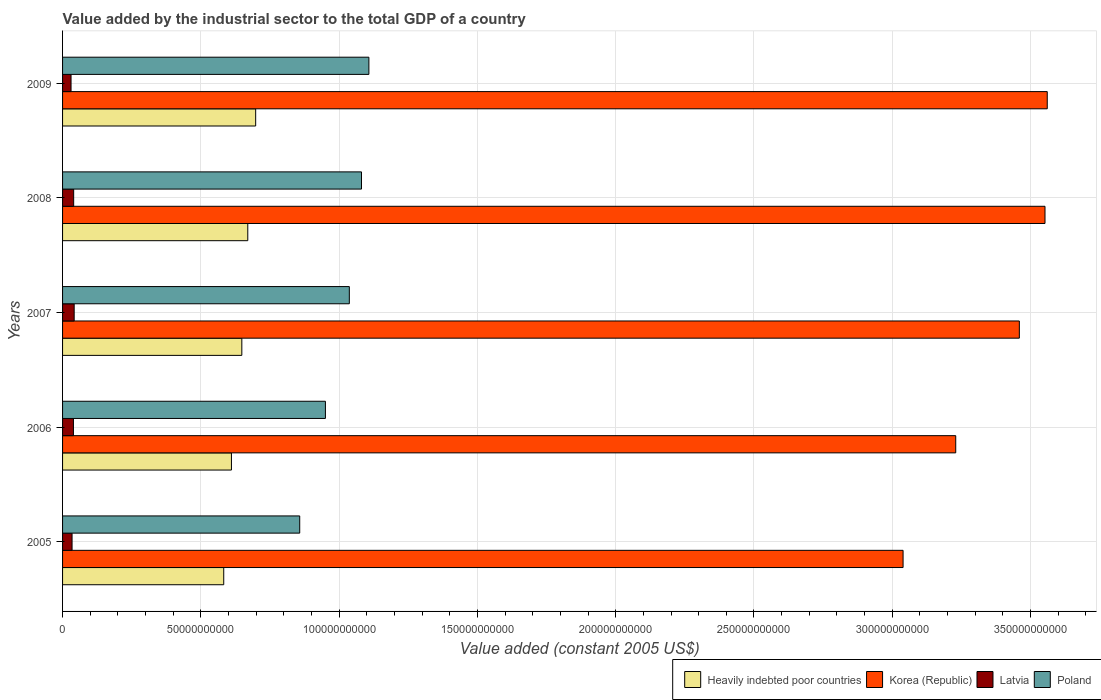How many different coloured bars are there?
Give a very brief answer. 4. How many bars are there on the 1st tick from the top?
Offer a very short reply. 4. In how many cases, is the number of bars for a given year not equal to the number of legend labels?
Keep it short and to the point. 0. What is the value added by the industrial sector in Korea (Republic) in 2008?
Provide a succinct answer. 3.55e+11. Across all years, what is the maximum value added by the industrial sector in Korea (Republic)?
Offer a terse response. 3.56e+11. Across all years, what is the minimum value added by the industrial sector in Latvia?
Give a very brief answer. 3.06e+09. In which year was the value added by the industrial sector in Latvia maximum?
Give a very brief answer. 2007. What is the total value added by the industrial sector in Poland in the graph?
Offer a very short reply. 5.03e+11. What is the difference between the value added by the industrial sector in Heavily indebted poor countries in 2005 and that in 2007?
Offer a very short reply. -6.54e+09. What is the difference between the value added by the industrial sector in Poland in 2006 and the value added by the industrial sector in Heavily indebted poor countries in 2008?
Your answer should be very brief. 2.81e+1. What is the average value added by the industrial sector in Poland per year?
Your response must be concise. 1.01e+11. In the year 2005, what is the difference between the value added by the industrial sector in Heavily indebted poor countries and value added by the industrial sector in Korea (Republic)?
Keep it short and to the point. -2.46e+11. In how many years, is the value added by the industrial sector in Poland greater than 340000000000 US$?
Make the answer very short. 0. What is the ratio of the value added by the industrial sector in Poland in 2005 to that in 2009?
Your answer should be compact. 0.77. Is the value added by the industrial sector in Poland in 2008 less than that in 2009?
Keep it short and to the point. Yes. What is the difference between the highest and the second highest value added by the industrial sector in Latvia?
Your answer should be compact. 1.83e+08. What is the difference between the highest and the lowest value added by the industrial sector in Poland?
Provide a short and direct response. 2.50e+1. In how many years, is the value added by the industrial sector in Korea (Republic) greater than the average value added by the industrial sector in Korea (Republic) taken over all years?
Provide a short and direct response. 3. Is it the case that in every year, the sum of the value added by the industrial sector in Heavily indebted poor countries and value added by the industrial sector in Korea (Republic) is greater than the sum of value added by the industrial sector in Latvia and value added by the industrial sector in Poland?
Provide a succinct answer. No. What does the 3rd bar from the top in 2007 represents?
Ensure brevity in your answer.  Korea (Republic). What does the 1st bar from the bottom in 2006 represents?
Provide a short and direct response. Heavily indebted poor countries. How many years are there in the graph?
Ensure brevity in your answer.  5. What is the difference between two consecutive major ticks on the X-axis?
Keep it short and to the point. 5.00e+1. Does the graph contain grids?
Keep it short and to the point. Yes. Where does the legend appear in the graph?
Keep it short and to the point. Bottom right. How many legend labels are there?
Ensure brevity in your answer.  4. What is the title of the graph?
Your response must be concise. Value added by the industrial sector to the total GDP of a country. What is the label or title of the X-axis?
Offer a terse response. Value added (constant 2005 US$). What is the label or title of the Y-axis?
Make the answer very short. Years. What is the Value added (constant 2005 US$) in Heavily indebted poor countries in 2005?
Provide a succinct answer. 5.83e+1. What is the Value added (constant 2005 US$) in Korea (Republic) in 2005?
Your answer should be compact. 3.04e+11. What is the Value added (constant 2005 US$) of Latvia in 2005?
Provide a short and direct response. 3.44e+09. What is the Value added (constant 2005 US$) of Poland in 2005?
Keep it short and to the point. 8.57e+1. What is the Value added (constant 2005 US$) of Heavily indebted poor countries in 2006?
Your response must be concise. 6.11e+1. What is the Value added (constant 2005 US$) in Korea (Republic) in 2006?
Your answer should be compact. 3.23e+11. What is the Value added (constant 2005 US$) in Latvia in 2006?
Offer a very short reply. 3.93e+09. What is the Value added (constant 2005 US$) in Poland in 2006?
Your answer should be very brief. 9.50e+1. What is the Value added (constant 2005 US$) of Heavily indebted poor countries in 2007?
Your answer should be very brief. 6.48e+1. What is the Value added (constant 2005 US$) of Korea (Republic) in 2007?
Your answer should be very brief. 3.46e+11. What is the Value added (constant 2005 US$) of Latvia in 2007?
Offer a very short reply. 4.20e+09. What is the Value added (constant 2005 US$) in Poland in 2007?
Offer a very short reply. 1.04e+11. What is the Value added (constant 2005 US$) of Heavily indebted poor countries in 2008?
Provide a short and direct response. 6.70e+1. What is the Value added (constant 2005 US$) in Korea (Republic) in 2008?
Your response must be concise. 3.55e+11. What is the Value added (constant 2005 US$) in Latvia in 2008?
Provide a short and direct response. 4.01e+09. What is the Value added (constant 2005 US$) of Poland in 2008?
Make the answer very short. 1.08e+11. What is the Value added (constant 2005 US$) of Heavily indebted poor countries in 2009?
Give a very brief answer. 6.98e+1. What is the Value added (constant 2005 US$) in Korea (Republic) in 2009?
Ensure brevity in your answer.  3.56e+11. What is the Value added (constant 2005 US$) of Latvia in 2009?
Give a very brief answer. 3.06e+09. What is the Value added (constant 2005 US$) in Poland in 2009?
Provide a short and direct response. 1.11e+11. Across all years, what is the maximum Value added (constant 2005 US$) in Heavily indebted poor countries?
Provide a short and direct response. 6.98e+1. Across all years, what is the maximum Value added (constant 2005 US$) of Korea (Republic)?
Your answer should be very brief. 3.56e+11. Across all years, what is the maximum Value added (constant 2005 US$) in Latvia?
Keep it short and to the point. 4.20e+09. Across all years, what is the maximum Value added (constant 2005 US$) in Poland?
Make the answer very short. 1.11e+11. Across all years, what is the minimum Value added (constant 2005 US$) of Heavily indebted poor countries?
Provide a succinct answer. 5.83e+1. Across all years, what is the minimum Value added (constant 2005 US$) of Korea (Republic)?
Make the answer very short. 3.04e+11. Across all years, what is the minimum Value added (constant 2005 US$) in Latvia?
Make the answer very short. 3.06e+09. Across all years, what is the minimum Value added (constant 2005 US$) in Poland?
Give a very brief answer. 8.57e+1. What is the total Value added (constant 2005 US$) in Heavily indebted poor countries in the graph?
Your answer should be very brief. 3.21e+11. What is the total Value added (constant 2005 US$) of Korea (Republic) in the graph?
Your response must be concise. 1.68e+12. What is the total Value added (constant 2005 US$) in Latvia in the graph?
Offer a very short reply. 1.86e+1. What is the total Value added (constant 2005 US$) of Poland in the graph?
Offer a very short reply. 5.03e+11. What is the difference between the Value added (constant 2005 US$) of Heavily indebted poor countries in 2005 and that in 2006?
Provide a succinct answer. -2.78e+09. What is the difference between the Value added (constant 2005 US$) of Korea (Republic) in 2005 and that in 2006?
Offer a terse response. -1.90e+1. What is the difference between the Value added (constant 2005 US$) of Latvia in 2005 and that in 2006?
Ensure brevity in your answer.  -4.95e+08. What is the difference between the Value added (constant 2005 US$) in Poland in 2005 and that in 2006?
Offer a very short reply. -9.30e+09. What is the difference between the Value added (constant 2005 US$) of Heavily indebted poor countries in 2005 and that in 2007?
Your answer should be very brief. -6.54e+09. What is the difference between the Value added (constant 2005 US$) of Korea (Republic) in 2005 and that in 2007?
Your answer should be compact. -4.20e+1. What is the difference between the Value added (constant 2005 US$) in Latvia in 2005 and that in 2007?
Give a very brief answer. -7.62e+08. What is the difference between the Value added (constant 2005 US$) in Poland in 2005 and that in 2007?
Provide a succinct answer. -1.79e+1. What is the difference between the Value added (constant 2005 US$) of Heavily indebted poor countries in 2005 and that in 2008?
Offer a terse response. -8.69e+09. What is the difference between the Value added (constant 2005 US$) of Korea (Republic) in 2005 and that in 2008?
Offer a terse response. -5.13e+1. What is the difference between the Value added (constant 2005 US$) in Latvia in 2005 and that in 2008?
Make the answer very short. -5.78e+08. What is the difference between the Value added (constant 2005 US$) of Poland in 2005 and that in 2008?
Provide a short and direct response. -2.23e+1. What is the difference between the Value added (constant 2005 US$) of Heavily indebted poor countries in 2005 and that in 2009?
Provide a short and direct response. -1.15e+1. What is the difference between the Value added (constant 2005 US$) of Korea (Republic) in 2005 and that in 2009?
Offer a terse response. -5.21e+1. What is the difference between the Value added (constant 2005 US$) in Latvia in 2005 and that in 2009?
Provide a succinct answer. 3.71e+08. What is the difference between the Value added (constant 2005 US$) of Poland in 2005 and that in 2009?
Provide a short and direct response. -2.50e+1. What is the difference between the Value added (constant 2005 US$) in Heavily indebted poor countries in 2006 and that in 2007?
Keep it short and to the point. -3.76e+09. What is the difference between the Value added (constant 2005 US$) of Korea (Republic) in 2006 and that in 2007?
Your answer should be compact. -2.30e+1. What is the difference between the Value added (constant 2005 US$) of Latvia in 2006 and that in 2007?
Provide a short and direct response. -2.67e+08. What is the difference between the Value added (constant 2005 US$) of Poland in 2006 and that in 2007?
Ensure brevity in your answer.  -8.64e+09. What is the difference between the Value added (constant 2005 US$) of Heavily indebted poor countries in 2006 and that in 2008?
Offer a terse response. -5.91e+09. What is the difference between the Value added (constant 2005 US$) of Korea (Republic) in 2006 and that in 2008?
Keep it short and to the point. -3.23e+1. What is the difference between the Value added (constant 2005 US$) in Latvia in 2006 and that in 2008?
Give a very brief answer. -8.38e+07. What is the difference between the Value added (constant 2005 US$) of Poland in 2006 and that in 2008?
Your answer should be compact. -1.30e+1. What is the difference between the Value added (constant 2005 US$) of Heavily indebted poor countries in 2006 and that in 2009?
Your response must be concise. -8.76e+09. What is the difference between the Value added (constant 2005 US$) in Korea (Republic) in 2006 and that in 2009?
Make the answer very short. -3.31e+1. What is the difference between the Value added (constant 2005 US$) of Latvia in 2006 and that in 2009?
Keep it short and to the point. 8.66e+08. What is the difference between the Value added (constant 2005 US$) of Poland in 2006 and that in 2009?
Offer a very short reply. -1.57e+1. What is the difference between the Value added (constant 2005 US$) of Heavily indebted poor countries in 2007 and that in 2008?
Keep it short and to the point. -2.15e+09. What is the difference between the Value added (constant 2005 US$) in Korea (Republic) in 2007 and that in 2008?
Ensure brevity in your answer.  -9.28e+09. What is the difference between the Value added (constant 2005 US$) in Latvia in 2007 and that in 2008?
Your answer should be compact. 1.83e+08. What is the difference between the Value added (constant 2005 US$) of Poland in 2007 and that in 2008?
Make the answer very short. -4.40e+09. What is the difference between the Value added (constant 2005 US$) of Heavily indebted poor countries in 2007 and that in 2009?
Provide a succinct answer. -5.00e+09. What is the difference between the Value added (constant 2005 US$) in Korea (Republic) in 2007 and that in 2009?
Offer a terse response. -1.01e+1. What is the difference between the Value added (constant 2005 US$) of Latvia in 2007 and that in 2009?
Your response must be concise. 1.13e+09. What is the difference between the Value added (constant 2005 US$) of Poland in 2007 and that in 2009?
Make the answer very short. -7.07e+09. What is the difference between the Value added (constant 2005 US$) in Heavily indebted poor countries in 2008 and that in 2009?
Your answer should be compact. -2.85e+09. What is the difference between the Value added (constant 2005 US$) in Korea (Republic) in 2008 and that in 2009?
Make the answer very short. -8.14e+08. What is the difference between the Value added (constant 2005 US$) of Latvia in 2008 and that in 2009?
Offer a very short reply. 9.50e+08. What is the difference between the Value added (constant 2005 US$) of Poland in 2008 and that in 2009?
Give a very brief answer. -2.67e+09. What is the difference between the Value added (constant 2005 US$) in Heavily indebted poor countries in 2005 and the Value added (constant 2005 US$) in Korea (Republic) in 2006?
Provide a short and direct response. -2.65e+11. What is the difference between the Value added (constant 2005 US$) of Heavily indebted poor countries in 2005 and the Value added (constant 2005 US$) of Latvia in 2006?
Give a very brief answer. 5.43e+1. What is the difference between the Value added (constant 2005 US$) in Heavily indebted poor countries in 2005 and the Value added (constant 2005 US$) in Poland in 2006?
Your response must be concise. -3.68e+1. What is the difference between the Value added (constant 2005 US$) of Korea (Republic) in 2005 and the Value added (constant 2005 US$) of Latvia in 2006?
Offer a terse response. 3.00e+11. What is the difference between the Value added (constant 2005 US$) of Korea (Republic) in 2005 and the Value added (constant 2005 US$) of Poland in 2006?
Your response must be concise. 2.09e+11. What is the difference between the Value added (constant 2005 US$) of Latvia in 2005 and the Value added (constant 2005 US$) of Poland in 2006?
Offer a terse response. -9.16e+1. What is the difference between the Value added (constant 2005 US$) in Heavily indebted poor countries in 2005 and the Value added (constant 2005 US$) in Korea (Republic) in 2007?
Provide a succinct answer. -2.88e+11. What is the difference between the Value added (constant 2005 US$) in Heavily indebted poor countries in 2005 and the Value added (constant 2005 US$) in Latvia in 2007?
Provide a short and direct response. 5.41e+1. What is the difference between the Value added (constant 2005 US$) in Heavily indebted poor countries in 2005 and the Value added (constant 2005 US$) in Poland in 2007?
Make the answer very short. -4.54e+1. What is the difference between the Value added (constant 2005 US$) in Korea (Republic) in 2005 and the Value added (constant 2005 US$) in Latvia in 2007?
Offer a terse response. 3.00e+11. What is the difference between the Value added (constant 2005 US$) in Korea (Republic) in 2005 and the Value added (constant 2005 US$) in Poland in 2007?
Offer a very short reply. 2.00e+11. What is the difference between the Value added (constant 2005 US$) in Latvia in 2005 and the Value added (constant 2005 US$) in Poland in 2007?
Offer a terse response. -1.00e+11. What is the difference between the Value added (constant 2005 US$) in Heavily indebted poor countries in 2005 and the Value added (constant 2005 US$) in Korea (Republic) in 2008?
Keep it short and to the point. -2.97e+11. What is the difference between the Value added (constant 2005 US$) in Heavily indebted poor countries in 2005 and the Value added (constant 2005 US$) in Latvia in 2008?
Your response must be concise. 5.43e+1. What is the difference between the Value added (constant 2005 US$) in Heavily indebted poor countries in 2005 and the Value added (constant 2005 US$) in Poland in 2008?
Your answer should be compact. -4.98e+1. What is the difference between the Value added (constant 2005 US$) in Korea (Republic) in 2005 and the Value added (constant 2005 US$) in Latvia in 2008?
Ensure brevity in your answer.  3.00e+11. What is the difference between the Value added (constant 2005 US$) of Korea (Republic) in 2005 and the Value added (constant 2005 US$) of Poland in 2008?
Provide a succinct answer. 1.96e+11. What is the difference between the Value added (constant 2005 US$) in Latvia in 2005 and the Value added (constant 2005 US$) in Poland in 2008?
Offer a very short reply. -1.05e+11. What is the difference between the Value added (constant 2005 US$) of Heavily indebted poor countries in 2005 and the Value added (constant 2005 US$) of Korea (Republic) in 2009?
Offer a terse response. -2.98e+11. What is the difference between the Value added (constant 2005 US$) of Heavily indebted poor countries in 2005 and the Value added (constant 2005 US$) of Latvia in 2009?
Your answer should be very brief. 5.52e+1. What is the difference between the Value added (constant 2005 US$) of Heavily indebted poor countries in 2005 and the Value added (constant 2005 US$) of Poland in 2009?
Provide a succinct answer. -5.25e+1. What is the difference between the Value added (constant 2005 US$) of Korea (Republic) in 2005 and the Value added (constant 2005 US$) of Latvia in 2009?
Your answer should be very brief. 3.01e+11. What is the difference between the Value added (constant 2005 US$) of Korea (Republic) in 2005 and the Value added (constant 2005 US$) of Poland in 2009?
Give a very brief answer. 1.93e+11. What is the difference between the Value added (constant 2005 US$) of Latvia in 2005 and the Value added (constant 2005 US$) of Poland in 2009?
Your answer should be very brief. -1.07e+11. What is the difference between the Value added (constant 2005 US$) in Heavily indebted poor countries in 2006 and the Value added (constant 2005 US$) in Korea (Republic) in 2007?
Provide a succinct answer. -2.85e+11. What is the difference between the Value added (constant 2005 US$) of Heavily indebted poor countries in 2006 and the Value added (constant 2005 US$) of Latvia in 2007?
Your response must be concise. 5.69e+1. What is the difference between the Value added (constant 2005 US$) in Heavily indebted poor countries in 2006 and the Value added (constant 2005 US$) in Poland in 2007?
Your answer should be very brief. -4.26e+1. What is the difference between the Value added (constant 2005 US$) of Korea (Republic) in 2006 and the Value added (constant 2005 US$) of Latvia in 2007?
Provide a short and direct response. 3.19e+11. What is the difference between the Value added (constant 2005 US$) of Korea (Republic) in 2006 and the Value added (constant 2005 US$) of Poland in 2007?
Your answer should be compact. 2.19e+11. What is the difference between the Value added (constant 2005 US$) in Latvia in 2006 and the Value added (constant 2005 US$) in Poland in 2007?
Give a very brief answer. -9.98e+1. What is the difference between the Value added (constant 2005 US$) of Heavily indebted poor countries in 2006 and the Value added (constant 2005 US$) of Korea (Republic) in 2008?
Your answer should be very brief. -2.94e+11. What is the difference between the Value added (constant 2005 US$) of Heavily indebted poor countries in 2006 and the Value added (constant 2005 US$) of Latvia in 2008?
Ensure brevity in your answer.  5.70e+1. What is the difference between the Value added (constant 2005 US$) in Heavily indebted poor countries in 2006 and the Value added (constant 2005 US$) in Poland in 2008?
Your answer should be very brief. -4.70e+1. What is the difference between the Value added (constant 2005 US$) in Korea (Republic) in 2006 and the Value added (constant 2005 US$) in Latvia in 2008?
Your response must be concise. 3.19e+11. What is the difference between the Value added (constant 2005 US$) in Korea (Republic) in 2006 and the Value added (constant 2005 US$) in Poland in 2008?
Ensure brevity in your answer.  2.15e+11. What is the difference between the Value added (constant 2005 US$) in Latvia in 2006 and the Value added (constant 2005 US$) in Poland in 2008?
Your response must be concise. -1.04e+11. What is the difference between the Value added (constant 2005 US$) in Heavily indebted poor countries in 2006 and the Value added (constant 2005 US$) in Korea (Republic) in 2009?
Give a very brief answer. -2.95e+11. What is the difference between the Value added (constant 2005 US$) in Heavily indebted poor countries in 2006 and the Value added (constant 2005 US$) in Latvia in 2009?
Give a very brief answer. 5.80e+1. What is the difference between the Value added (constant 2005 US$) of Heavily indebted poor countries in 2006 and the Value added (constant 2005 US$) of Poland in 2009?
Make the answer very short. -4.97e+1. What is the difference between the Value added (constant 2005 US$) in Korea (Republic) in 2006 and the Value added (constant 2005 US$) in Latvia in 2009?
Your answer should be very brief. 3.20e+11. What is the difference between the Value added (constant 2005 US$) of Korea (Republic) in 2006 and the Value added (constant 2005 US$) of Poland in 2009?
Keep it short and to the point. 2.12e+11. What is the difference between the Value added (constant 2005 US$) of Latvia in 2006 and the Value added (constant 2005 US$) of Poland in 2009?
Offer a very short reply. -1.07e+11. What is the difference between the Value added (constant 2005 US$) in Heavily indebted poor countries in 2007 and the Value added (constant 2005 US$) in Korea (Republic) in 2008?
Make the answer very short. -2.90e+11. What is the difference between the Value added (constant 2005 US$) in Heavily indebted poor countries in 2007 and the Value added (constant 2005 US$) in Latvia in 2008?
Your answer should be very brief. 6.08e+1. What is the difference between the Value added (constant 2005 US$) in Heavily indebted poor countries in 2007 and the Value added (constant 2005 US$) in Poland in 2008?
Your answer should be very brief. -4.33e+1. What is the difference between the Value added (constant 2005 US$) in Korea (Republic) in 2007 and the Value added (constant 2005 US$) in Latvia in 2008?
Your answer should be very brief. 3.42e+11. What is the difference between the Value added (constant 2005 US$) in Korea (Republic) in 2007 and the Value added (constant 2005 US$) in Poland in 2008?
Provide a short and direct response. 2.38e+11. What is the difference between the Value added (constant 2005 US$) in Latvia in 2007 and the Value added (constant 2005 US$) in Poland in 2008?
Offer a very short reply. -1.04e+11. What is the difference between the Value added (constant 2005 US$) of Heavily indebted poor countries in 2007 and the Value added (constant 2005 US$) of Korea (Republic) in 2009?
Offer a very short reply. -2.91e+11. What is the difference between the Value added (constant 2005 US$) of Heavily indebted poor countries in 2007 and the Value added (constant 2005 US$) of Latvia in 2009?
Provide a succinct answer. 6.18e+1. What is the difference between the Value added (constant 2005 US$) in Heavily indebted poor countries in 2007 and the Value added (constant 2005 US$) in Poland in 2009?
Provide a short and direct response. -4.59e+1. What is the difference between the Value added (constant 2005 US$) in Korea (Republic) in 2007 and the Value added (constant 2005 US$) in Latvia in 2009?
Your response must be concise. 3.43e+11. What is the difference between the Value added (constant 2005 US$) of Korea (Republic) in 2007 and the Value added (constant 2005 US$) of Poland in 2009?
Give a very brief answer. 2.35e+11. What is the difference between the Value added (constant 2005 US$) in Latvia in 2007 and the Value added (constant 2005 US$) in Poland in 2009?
Offer a terse response. -1.07e+11. What is the difference between the Value added (constant 2005 US$) of Heavily indebted poor countries in 2008 and the Value added (constant 2005 US$) of Korea (Republic) in 2009?
Offer a terse response. -2.89e+11. What is the difference between the Value added (constant 2005 US$) in Heavily indebted poor countries in 2008 and the Value added (constant 2005 US$) in Latvia in 2009?
Give a very brief answer. 6.39e+1. What is the difference between the Value added (constant 2005 US$) in Heavily indebted poor countries in 2008 and the Value added (constant 2005 US$) in Poland in 2009?
Keep it short and to the point. -4.38e+1. What is the difference between the Value added (constant 2005 US$) of Korea (Republic) in 2008 and the Value added (constant 2005 US$) of Latvia in 2009?
Offer a very short reply. 3.52e+11. What is the difference between the Value added (constant 2005 US$) in Korea (Republic) in 2008 and the Value added (constant 2005 US$) in Poland in 2009?
Provide a succinct answer. 2.44e+11. What is the difference between the Value added (constant 2005 US$) in Latvia in 2008 and the Value added (constant 2005 US$) in Poland in 2009?
Offer a terse response. -1.07e+11. What is the average Value added (constant 2005 US$) in Heavily indebted poor countries per year?
Offer a very short reply. 6.42e+1. What is the average Value added (constant 2005 US$) of Korea (Republic) per year?
Offer a very short reply. 3.37e+11. What is the average Value added (constant 2005 US$) in Latvia per year?
Make the answer very short. 3.73e+09. What is the average Value added (constant 2005 US$) in Poland per year?
Give a very brief answer. 1.01e+11. In the year 2005, what is the difference between the Value added (constant 2005 US$) in Heavily indebted poor countries and Value added (constant 2005 US$) in Korea (Republic)?
Give a very brief answer. -2.46e+11. In the year 2005, what is the difference between the Value added (constant 2005 US$) of Heavily indebted poor countries and Value added (constant 2005 US$) of Latvia?
Offer a terse response. 5.48e+1. In the year 2005, what is the difference between the Value added (constant 2005 US$) of Heavily indebted poor countries and Value added (constant 2005 US$) of Poland?
Provide a succinct answer. -2.75e+1. In the year 2005, what is the difference between the Value added (constant 2005 US$) of Korea (Republic) and Value added (constant 2005 US$) of Latvia?
Ensure brevity in your answer.  3.00e+11. In the year 2005, what is the difference between the Value added (constant 2005 US$) of Korea (Republic) and Value added (constant 2005 US$) of Poland?
Give a very brief answer. 2.18e+11. In the year 2005, what is the difference between the Value added (constant 2005 US$) in Latvia and Value added (constant 2005 US$) in Poland?
Make the answer very short. -8.23e+1. In the year 2006, what is the difference between the Value added (constant 2005 US$) in Heavily indebted poor countries and Value added (constant 2005 US$) in Korea (Republic)?
Provide a succinct answer. -2.62e+11. In the year 2006, what is the difference between the Value added (constant 2005 US$) in Heavily indebted poor countries and Value added (constant 2005 US$) in Latvia?
Your answer should be compact. 5.71e+1. In the year 2006, what is the difference between the Value added (constant 2005 US$) of Heavily indebted poor countries and Value added (constant 2005 US$) of Poland?
Provide a succinct answer. -3.40e+1. In the year 2006, what is the difference between the Value added (constant 2005 US$) in Korea (Republic) and Value added (constant 2005 US$) in Latvia?
Provide a short and direct response. 3.19e+11. In the year 2006, what is the difference between the Value added (constant 2005 US$) in Korea (Republic) and Value added (constant 2005 US$) in Poland?
Give a very brief answer. 2.28e+11. In the year 2006, what is the difference between the Value added (constant 2005 US$) in Latvia and Value added (constant 2005 US$) in Poland?
Ensure brevity in your answer.  -9.11e+1. In the year 2007, what is the difference between the Value added (constant 2005 US$) in Heavily indebted poor countries and Value added (constant 2005 US$) in Korea (Republic)?
Keep it short and to the point. -2.81e+11. In the year 2007, what is the difference between the Value added (constant 2005 US$) in Heavily indebted poor countries and Value added (constant 2005 US$) in Latvia?
Offer a very short reply. 6.06e+1. In the year 2007, what is the difference between the Value added (constant 2005 US$) in Heavily indebted poor countries and Value added (constant 2005 US$) in Poland?
Your response must be concise. -3.89e+1. In the year 2007, what is the difference between the Value added (constant 2005 US$) of Korea (Republic) and Value added (constant 2005 US$) of Latvia?
Your answer should be compact. 3.42e+11. In the year 2007, what is the difference between the Value added (constant 2005 US$) in Korea (Republic) and Value added (constant 2005 US$) in Poland?
Offer a terse response. 2.42e+11. In the year 2007, what is the difference between the Value added (constant 2005 US$) in Latvia and Value added (constant 2005 US$) in Poland?
Keep it short and to the point. -9.95e+1. In the year 2008, what is the difference between the Value added (constant 2005 US$) in Heavily indebted poor countries and Value added (constant 2005 US$) in Korea (Republic)?
Provide a short and direct response. -2.88e+11. In the year 2008, what is the difference between the Value added (constant 2005 US$) of Heavily indebted poor countries and Value added (constant 2005 US$) of Latvia?
Your answer should be very brief. 6.30e+1. In the year 2008, what is the difference between the Value added (constant 2005 US$) of Heavily indebted poor countries and Value added (constant 2005 US$) of Poland?
Keep it short and to the point. -4.11e+1. In the year 2008, what is the difference between the Value added (constant 2005 US$) in Korea (Republic) and Value added (constant 2005 US$) in Latvia?
Offer a terse response. 3.51e+11. In the year 2008, what is the difference between the Value added (constant 2005 US$) of Korea (Republic) and Value added (constant 2005 US$) of Poland?
Give a very brief answer. 2.47e+11. In the year 2008, what is the difference between the Value added (constant 2005 US$) in Latvia and Value added (constant 2005 US$) in Poland?
Make the answer very short. -1.04e+11. In the year 2009, what is the difference between the Value added (constant 2005 US$) in Heavily indebted poor countries and Value added (constant 2005 US$) in Korea (Republic)?
Offer a terse response. -2.86e+11. In the year 2009, what is the difference between the Value added (constant 2005 US$) of Heavily indebted poor countries and Value added (constant 2005 US$) of Latvia?
Ensure brevity in your answer.  6.68e+1. In the year 2009, what is the difference between the Value added (constant 2005 US$) of Heavily indebted poor countries and Value added (constant 2005 US$) of Poland?
Give a very brief answer. -4.09e+1. In the year 2009, what is the difference between the Value added (constant 2005 US$) of Korea (Republic) and Value added (constant 2005 US$) of Latvia?
Ensure brevity in your answer.  3.53e+11. In the year 2009, what is the difference between the Value added (constant 2005 US$) of Korea (Republic) and Value added (constant 2005 US$) of Poland?
Your answer should be very brief. 2.45e+11. In the year 2009, what is the difference between the Value added (constant 2005 US$) of Latvia and Value added (constant 2005 US$) of Poland?
Your answer should be very brief. -1.08e+11. What is the ratio of the Value added (constant 2005 US$) in Heavily indebted poor countries in 2005 to that in 2006?
Offer a very short reply. 0.95. What is the ratio of the Value added (constant 2005 US$) of Korea (Republic) in 2005 to that in 2006?
Provide a short and direct response. 0.94. What is the ratio of the Value added (constant 2005 US$) in Latvia in 2005 to that in 2006?
Keep it short and to the point. 0.87. What is the ratio of the Value added (constant 2005 US$) in Poland in 2005 to that in 2006?
Your response must be concise. 0.9. What is the ratio of the Value added (constant 2005 US$) of Heavily indebted poor countries in 2005 to that in 2007?
Keep it short and to the point. 0.9. What is the ratio of the Value added (constant 2005 US$) of Korea (Republic) in 2005 to that in 2007?
Your answer should be compact. 0.88. What is the ratio of the Value added (constant 2005 US$) of Latvia in 2005 to that in 2007?
Ensure brevity in your answer.  0.82. What is the ratio of the Value added (constant 2005 US$) of Poland in 2005 to that in 2007?
Provide a succinct answer. 0.83. What is the ratio of the Value added (constant 2005 US$) in Heavily indebted poor countries in 2005 to that in 2008?
Give a very brief answer. 0.87. What is the ratio of the Value added (constant 2005 US$) of Korea (Republic) in 2005 to that in 2008?
Keep it short and to the point. 0.86. What is the ratio of the Value added (constant 2005 US$) in Latvia in 2005 to that in 2008?
Make the answer very short. 0.86. What is the ratio of the Value added (constant 2005 US$) in Poland in 2005 to that in 2008?
Provide a short and direct response. 0.79. What is the ratio of the Value added (constant 2005 US$) of Heavily indebted poor countries in 2005 to that in 2009?
Your answer should be compact. 0.83. What is the ratio of the Value added (constant 2005 US$) of Korea (Republic) in 2005 to that in 2009?
Make the answer very short. 0.85. What is the ratio of the Value added (constant 2005 US$) in Latvia in 2005 to that in 2009?
Provide a short and direct response. 1.12. What is the ratio of the Value added (constant 2005 US$) in Poland in 2005 to that in 2009?
Your answer should be very brief. 0.77. What is the ratio of the Value added (constant 2005 US$) of Heavily indebted poor countries in 2006 to that in 2007?
Your answer should be compact. 0.94. What is the ratio of the Value added (constant 2005 US$) of Korea (Republic) in 2006 to that in 2007?
Make the answer very short. 0.93. What is the ratio of the Value added (constant 2005 US$) in Latvia in 2006 to that in 2007?
Make the answer very short. 0.94. What is the ratio of the Value added (constant 2005 US$) of Poland in 2006 to that in 2007?
Your response must be concise. 0.92. What is the ratio of the Value added (constant 2005 US$) of Heavily indebted poor countries in 2006 to that in 2008?
Offer a very short reply. 0.91. What is the ratio of the Value added (constant 2005 US$) in Korea (Republic) in 2006 to that in 2008?
Provide a succinct answer. 0.91. What is the ratio of the Value added (constant 2005 US$) of Latvia in 2006 to that in 2008?
Your answer should be very brief. 0.98. What is the ratio of the Value added (constant 2005 US$) of Poland in 2006 to that in 2008?
Your answer should be very brief. 0.88. What is the ratio of the Value added (constant 2005 US$) in Heavily indebted poor countries in 2006 to that in 2009?
Ensure brevity in your answer.  0.87. What is the ratio of the Value added (constant 2005 US$) in Korea (Republic) in 2006 to that in 2009?
Give a very brief answer. 0.91. What is the ratio of the Value added (constant 2005 US$) of Latvia in 2006 to that in 2009?
Keep it short and to the point. 1.28. What is the ratio of the Value added (constant 2005 US$) in Poland in 2006 to that in 2009?
Your answer should be compact. 0.86. What is the ratio of the Value added (constant 2005 US$) in Heavily indebted poor countries in 2007 to that in 2008?
Provide a succinct answer. 0.97. What is the ratio of the Value added (constant 2005 US$) of Korea (Republic) in 2007 to that in 2008?
Your answer should be compact. 0.97. What is the ratio of the Value added (constant 2005 US$) of Latvia in 2007 to that in 2008?
Your answer should be compact. 1.05. What is the ratio of the Value added (constant 2005 US$) of Poland in 2007 to that in 2008?
Offer a terse response. 0.96. What is the ratio of the Value added (constant 2005 US$) of Heavily indebted poor countries in 2007 to that in 2009?
Give a very brief answer. 0.93. What is the ratio of the Value added (constant 2005 US$) in Korea (Republic) in 2007 to that in 2009?
Give a very brief answer. 0.97. What is the ratio of the Value added (constant 2005 US$) in Latvia in 2007 to that in 2009?
Your response must be concise. 1.37. What is the ratio of the Value added (constant 2005 US$) in Poland in 2007 to that in 2009?
Offer a very short reply. 0.94. What is the ratio of the Value added (constant 2005 US$) of Heavily indebted poor countries in 2008 to that in 2009?
Ensure brevity in your answer.  0.96. What is the ratio of the Value added (constant 2005 US$) in Korea (Republic) in 2008 to that in 2009?
Your response must be concise. 1. What is the ratio of the Value added (constant 2005 US$) in Latvia in 2008 to that in 2009?
Keep it short and to the point. 1.31. What is the ratio of the Value added (constant 2005 US$) in Poland in 2008 to that in 2009?
Your answer should be compact. 0.98. What is the difference between the highest and the second highest Value added (constant 2005 US$) in Heavily indebted poor countries?
Make the answer very short. 2.85e+09. What is the difference between the highest and the second highest Value added (constant 2005 US$) in Korea (Republic)?
Provide a succinct answer. 8.14e+08. What is the difference between the highest and the second highest Value added (constant 2005 US$) in Latvia?
Make the answer very short. 1.83e+08. What is the difference between the highest and the second highest Value added (constant 2005 US$) in Poland?
Your response must be concise. 2.67e+09. What is the difference between the highest and the lowest Value added (constant 2005 US$) in Heavily indebted poor countries?
Ensure brevity in your answer.  1.15e+1. What is the difference between the highest and the lowest Value added (constant 2005 US$) of Korea (Republic)?
Give a very brief answer. 5.21e+1. What is the difference between the highest and the lowest Value added (constant 2005 US$) in Latvia?
Give a very brief answer. 1.13e+09. What is the difference between the highest and the lowest Value added (constant 2005 US$) in Poland?
Your response must be concise. 2.50e+1. 